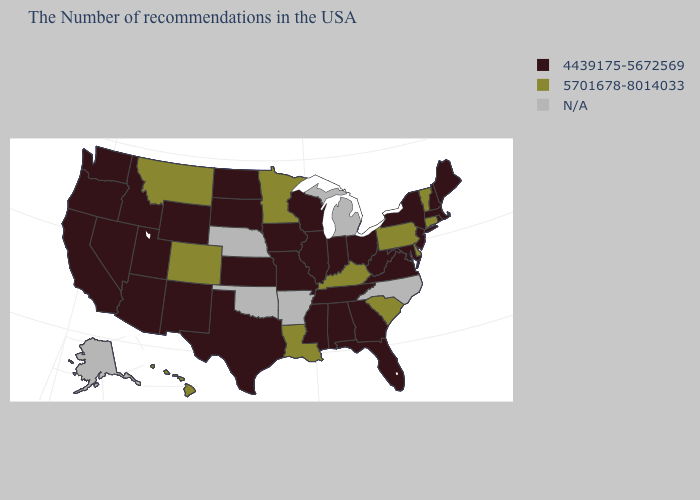What is the value of Utah?
Quick response, please. 4439175-5672569. Among the states that border North Carolina , which have the lowest value?
Concise answer only. Virginia, Georgia, Tennessee. Does the map have missing data?
Give a very brief answer. Yes. What is the value of Ohio?
Keep it brief. 4439175-5672569. What is the value of Connecticut?
Be succinct. 5701678-8014033. Name the states that have a value in the range N/A?
Short answer required. North Carolina, Michigan, Arkansas, Nebraska, Oklahoma, Alaska. Does the map have missing data?
Keep it brief. Yes. Does Colorado have the lowest value in the USA?
Give a very brief answer. No. Does Kentucky have the highest value in the USA?
Write a very short answer. Yes. What is the value of Maryland?
Write a very short answer. 4439175-5672569. Name the states that have a value in the range N/A?
Be succinct. North Carolina, Michigan, Arkansas, Nebraska, Oklahoma, Alaska. What is the value of Vermont?
Keep it brief. 5701678-8014033. Name the states that have a value in the range 5701678-8014033?
Be succinct. Vermont, Connecticut, Delaware, Pennsylvania, South Carolina, Kentucky, Louisiana, Minnesota, Colorado, Montana, Hawaii. Name the states that have a value in the range 5701678-8014033?
Give a very brief answer. Vermont, Connecticut, Delaware, Pennsylvania, South Carolina, Kentucky, Louisiana, Minnesota, Colorado, Montana, Hawaii. 